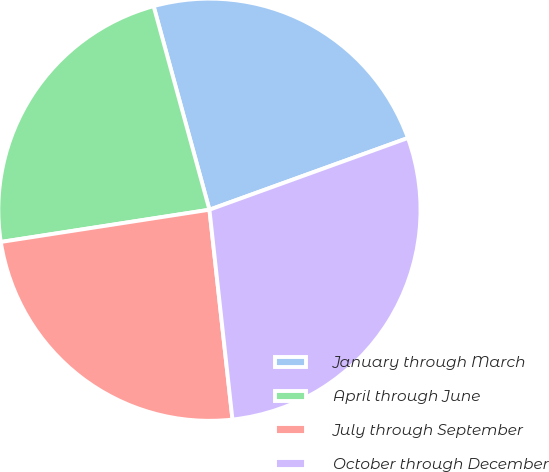Convert chart to OTSL. <chart><loc_0><loc_0><loc_500><loc_500><pie_chart><fcel>January through March<fcel>April through June<fcel>July through September<fcel>October through December<nl><fcel>23.74%<fcel>23.18%<fcel>24.3%<fcel>28.78%<nl></chart> 